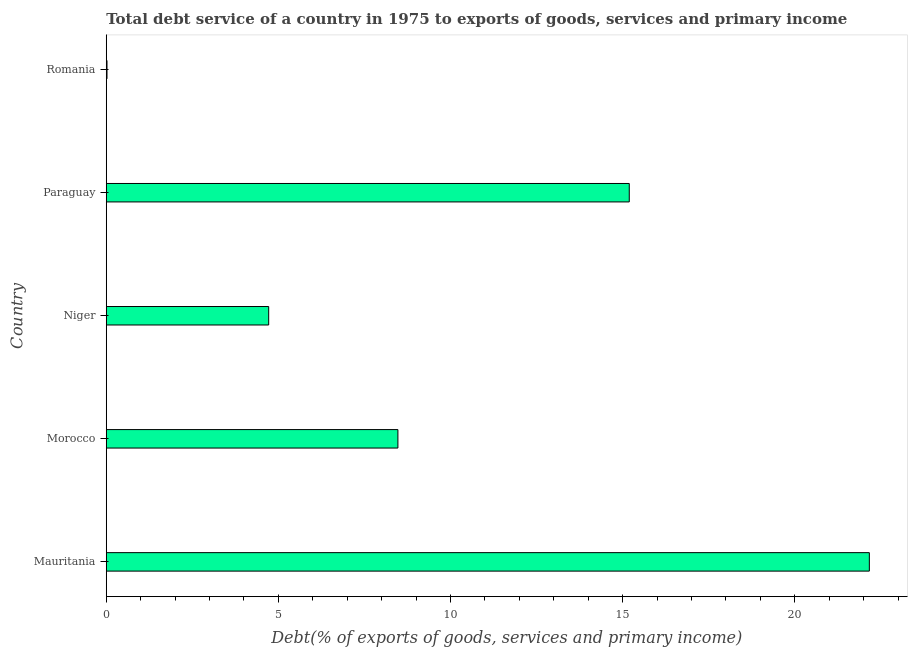Does the graph contain grids?
Your response must be concise. No. What is the title of the graph?
Your answer should be compact. Total debt service of a country in 1975 to exports of goods, services and primary income. What is the label or title of the X-axis?
Offer a terse response. Debt(% of exports of goods, services and primary income). What is the label or title of the Y-axis?
Offer a terse response. Country. What is the total debt service in Niger?
Your answer should be compact. 4.72. Across all countries, what is the maximum total debt service?
Your response must be concise. 22.16. Across all countries, what is the minimum total debt service?
Offer a terse response. 0.02. In which country was the total debt service maximum?
Offer a very short reply. Mauritania. In which country was the total debt service minimum?
Your response must be concise. Romania. What is the sum of the total debt service?
Your response must be concise. 50.57. What is the difference between the total debt service in Paraguay and Romania?
Give a very brief answer. 15.17. What is the average total debt service per country?
Give a very brief answer. 10.11. What is the median total debt service?
Offer a terse response. 8.47. In how many countries, is the total debt service greater than 22 %?
Offer a very short reply. 1. What is the ratio of the total debt service in Mauritania to that in Morocco?
Your answer should be very brief. 2.62. Is the total debt service in Niger less than that in Paraguay?
Offer a terse response. Yes. What is the difference between the highest and the second highest total debt service?
Your answer should be very brief. 6.97. What is the difference between the highest and the lowest total debt service?
Your response must be concise. 22.14. What is the difference between two consecutive major ticks on the X-axis?
Make the answer very short. 5. Are the values on the major ticks of X-axis written in scientific E-notation?
Ensure brevity in your answer.  No. What is the Debt(% of exports of goods, services and primary income) in Mauritania?
Ensure brevity in your answer.  22.16. What is the Debt(% of exports of goods, services and primary income) in Morocco?
Ensure brevity in your answer.  8.47. What is the Debt(% of exports of goods, services and primary income) of Niger?
Your response must be concise. 4.72. What is the Debt(% of exports of goods, services and primary income) in Paraguay?
Offer a very short reply. 15.19. What is the Debt(% of exports of goods, services and primary income) in Romania?
Your answer should be compact. 0.02. What is the difference between the Debt(% of exports of goods, services and primary income) in Mauritania and Morocco?
Your answer should be very brief. 13.69. What is the difference between the Debt(% of exports of goods, services and primary income) in Mauritania and Niger?
Ensure brevity in your answer.  17.45. What is the difference between the Debt(% of exports of goods, services and primary income) in Mauritania and Paraguay?
Your answer should be compact. 6.97. What is the difference between the Debt(% of exports of goods, services and primary income) in Mauritania and Romania?
Provide a short and direct response. 22.14. What is the difference between the Debt(% of exports of goods, services and primary income) in Morocco and Niger?
Your answer should be compact. 3.75. What is the difference between the Debt(% of exports of goods, services and primary income) in Morocco and Paraguay?
Your answer should be very brief. -6.72. What is the difference between the Debt(% of exports of goods, services and primary income) in Morocco and Romania?
Make the answer very short. 8.45. What is the difference between the Debt(% of exports of goods, services and primary income) in Niger and Paraguay?
Your response must be concise. -10.47. What is the difference between the Debt(% of exports of goods, services and primary income) in Niger and Romania?
Keep it short and to the point. 4.7. What is the difference between the Debt(% of exports of goods, services and primary income) in Paraguay and Romania?
Provide a succinct answer. 15.17. What is the ratio of the Debt(% of exports of goods, services and primary income) in Mauritania to that in Morocco?
Your answer should be very brief. 2.62. What is the ratio of the Debt(% of exports of goods, services and primary income) in Mauritania to that in Niger?
Ensure brevity in your answer.  4.7. What is the ratio of the Debt(% of exports of goods, services and primary income) in Mauritania to that in Paraguay?
Keep it short and to the point. 1.46. What is the ratio of the Debt(% of exports of goods, services and primary income) in Mauritania to that in Romania?
Make the answer very short. 1010.72. What is the ratio of the Debt(% of exports of goods, services and primary income) in Morocco to that in Niger?
Make the answer very short. 1.8. What is the ratio of the Debt(% of exports of goods, services and primary income) in Morocco to that in Paraguay?
Ensure brevity in your answer.  0.56. What is the ratio of the Debt(% of exports of goods, services and primary income) in Morocco to that in Romania?
Your answer should be compact. 386.31. What is the ratio of the Debt(% of exports of goods, services and primary income) in Niger to that in Paraguay?
Provide a succinct answer. 0.31. What is the ratio of the Debt(% of exports of goods, services and primary income) in Niger to that in Romania?
Your answer should be very brief. 215.15. What is the ratio of the Debt(% of exports of goods, services and primary income) in Paraguay to that in Romania?
Make the answer very short. 692.74. 